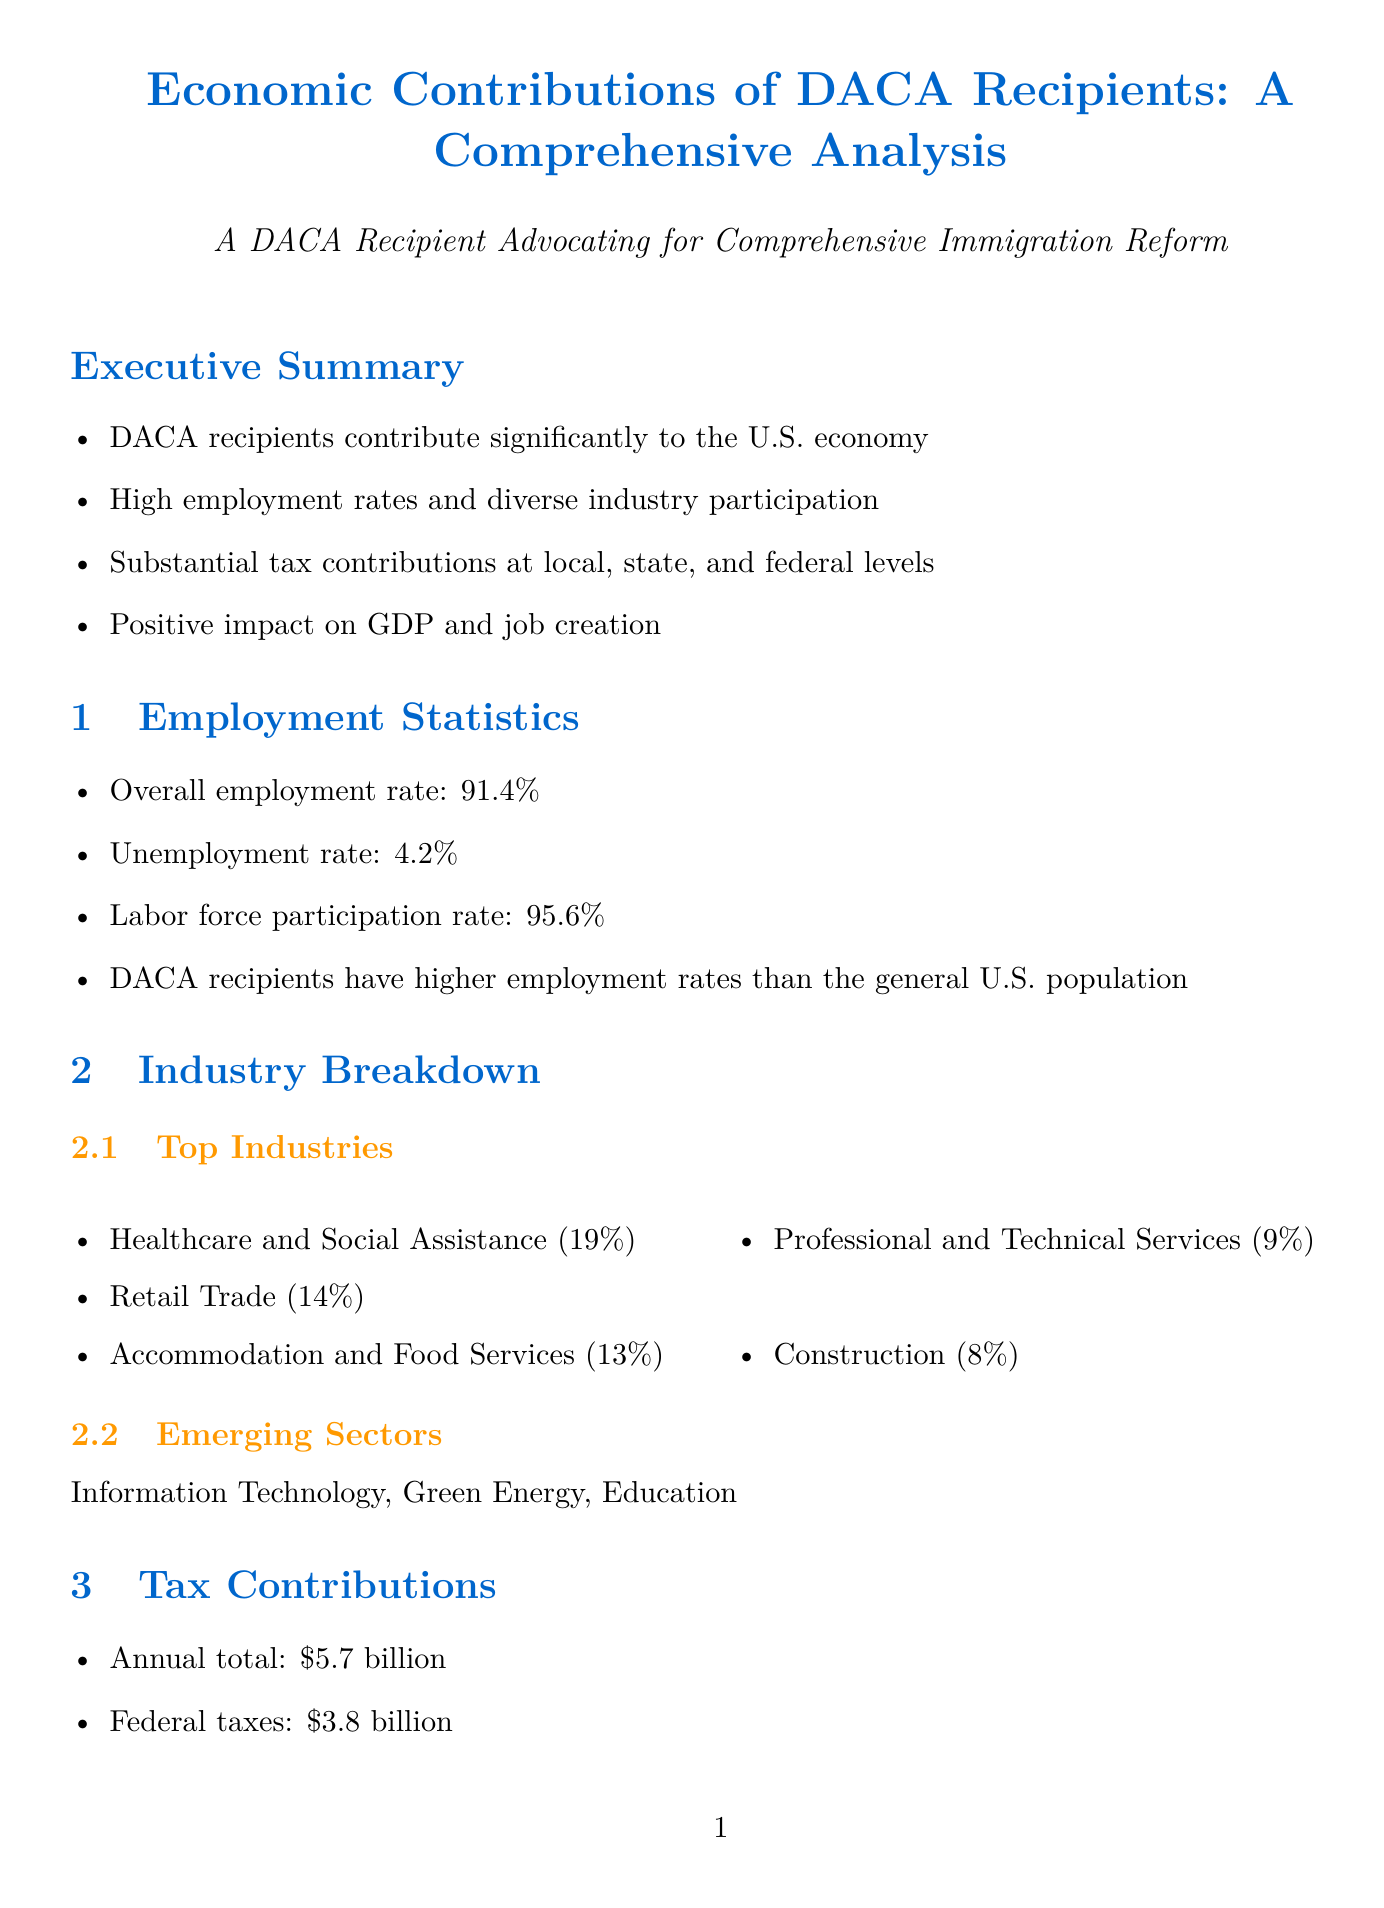What is the overall employment rate for DACA recipients? The overall employment rate is a specific statistic presented in the employment statistics section of the document.
Answer: 91.4% What is the unemployment rate among DACA recipients? The unemployment rate is another specific statistic provided in the employment statistics section.
Answer: 4.2% How much do DACA recipients contribute in annual federal taxes? This value is found in the tax contributions section, detailing specific contributions made by DACA recipients.
Answer: $3.8 billion Which industry has the highest percentage of DACA recipient employment? This information is located in the industry breakdown, indicating the top industry for employment.
Answer: Healthcare and Social Assistance What is the estimated GDP contribution of DACA recipients annually? The GDP contribution is a key economic impact statistic mentioned in the economic impact section.
Answer: $42 billion annually What percentage of DACA recipients have a bachelor’s degree or higher? This statistic is found in the educational attainment section, highlighting educational levels among DACA recipients.
Answer: 46% What is the potential GDP loss if DACA is terminated over a decade? This projection is stated in the policy implications section concerning the impact of terminating DACA.
Answer: $280 billion How many jobs do DACA recipients support indirectly? The document provides an estimate of job creation associated with DACA recipients in the economic impact section.
Answer: 200,000 jobs supported indirectly What percentage of DACA recipients are pursuing higher education? This statistic comes from the educational attainment section, which indicates ongoing education levels.
Answer: 38% 